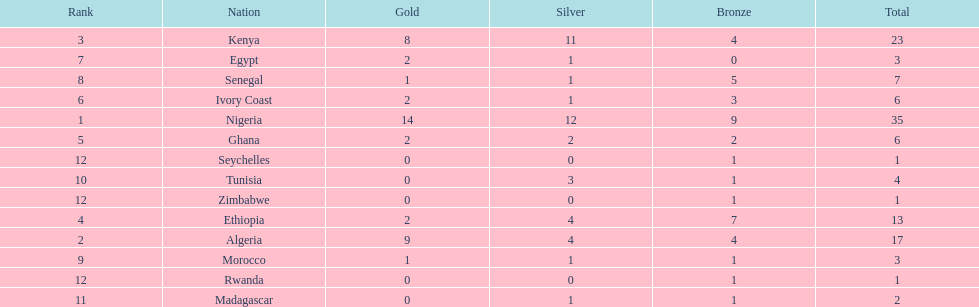Which nations have won only one medal? Rwanda, Zimbabwe, Seychelles. 